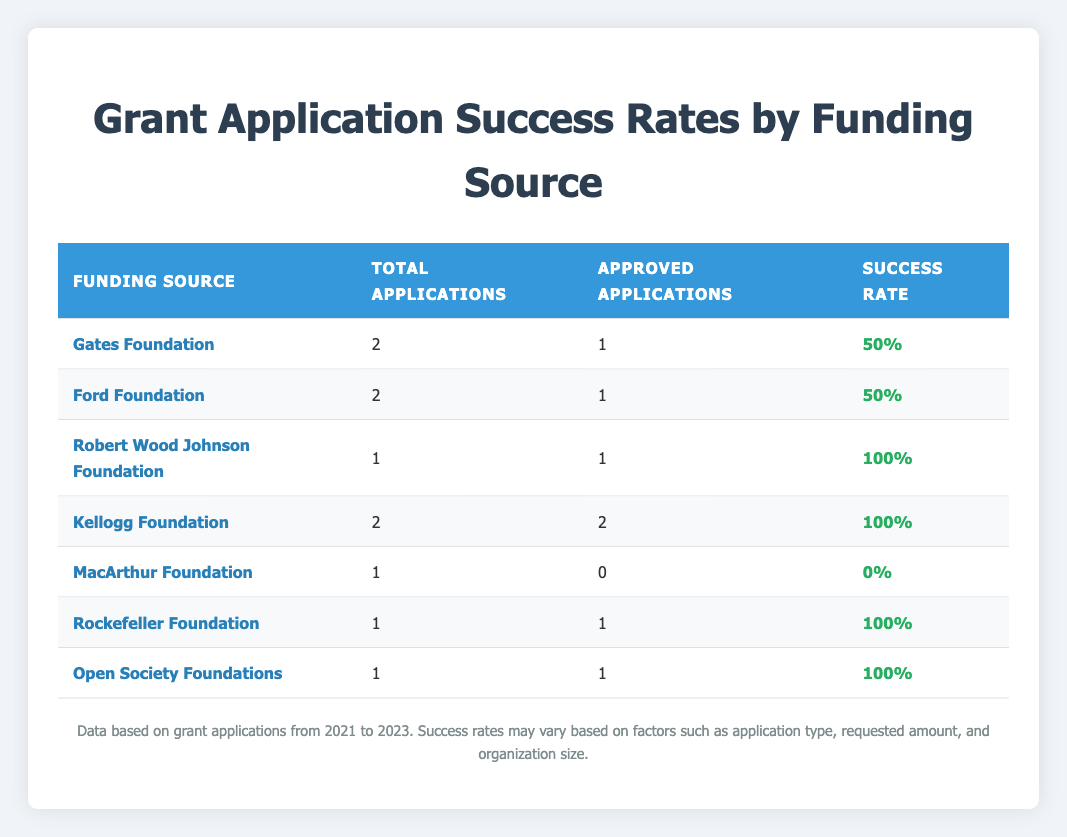What is the success rate for the Gates Foundation? The Gates Foundation has 2 total applications listed in the table, with 1 approved application. The success rate is calculated as (1 approved / 2 total) * 100% = 50%.
Answer: 50% What is the funding source with the highest success rate? The Kellogg Foundation has 2 total applications and both were approved, resulting in a success rate of 100%. This is the highest success rate among all funding sources listed.
Answer: Kellogg Foundation How many total applications were submitted to the Rockefeller Foundation? The table shows that there was 1 application submitted to the Rockefeller Foundation, which is indicated in the row corresponding to that funding source.
Answer: 1 Did the MacArthur Foundation have any approved applications? The MacArthur Foundation has 1 total application recorded, and it shows 0 approved applications. Thus, the answer is no, there were no approved applications.
Answer: No What is the average success rate of all foundations listed? The success rates are 50%, 50%, 100%, 100%, 0%, 100%, and 100% for the respective foundations. The average is calculated as (50 + 50 + 100 + 100 + 0 + 100 + 100) / 7 = 57.14%.
Answer: 57.14% Which funding source had the maximum number of applications approved? The Kellogg Foundation approved 2 applications out of its 2 submitted. This is the maximum number of applications approved for any funding source listed in the table.
Answer: Kellogg Foundation How many total applications were approved across all funding sources? The table lists the number of approved applications: 1 (Gates) + 1 (Ford) + 1 (Robert Wood Johnson) + 2 (Kellogg) + 0 (MacArthur) + 1 (Rockefeller) + 1 (Open Society) = 7 total approved applications.
Answer: 7 Did any of the foundations have a success rate of 0%? Yes, the MacArthur Foundation had a success rate of 0% since it had 0 approved applications out of 1 total application.
Answer: Yes How many applications were submitted to the Ford Foundation and what was their success rate? The Ford Foundation had 2 applications submitted, of which 1 was approved. The success rate is calculated as (1 approved / 2 total) * 100% = 50%. Therefore, the answer includes both the total applications and the success rate.
Answer: 2 applications, 50% success rate 